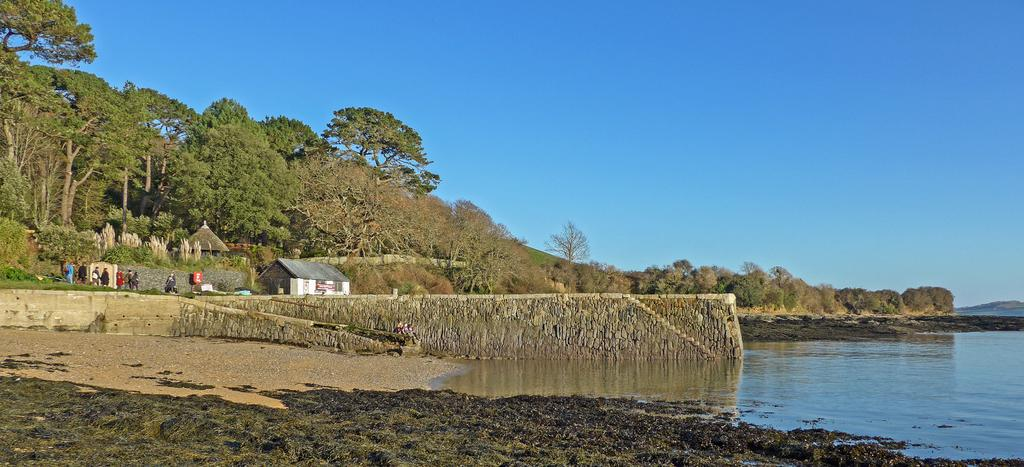What is the primary element visible in the image? There is water in the image. What type of structure can be seen in the image? There is a wall in the image. What type of buildings are present in the image? There are houses in the image. Who or what is present in the image? There is a group of people in the image. What type of vegetation is visible in the image? There is grass and trees in the image. What is visible at the top of the image? The sky is visible at the top of the image. What type of scarf is being worn by the trees in the image? There are no scarves present in the image, as trees do not wear clothing. 